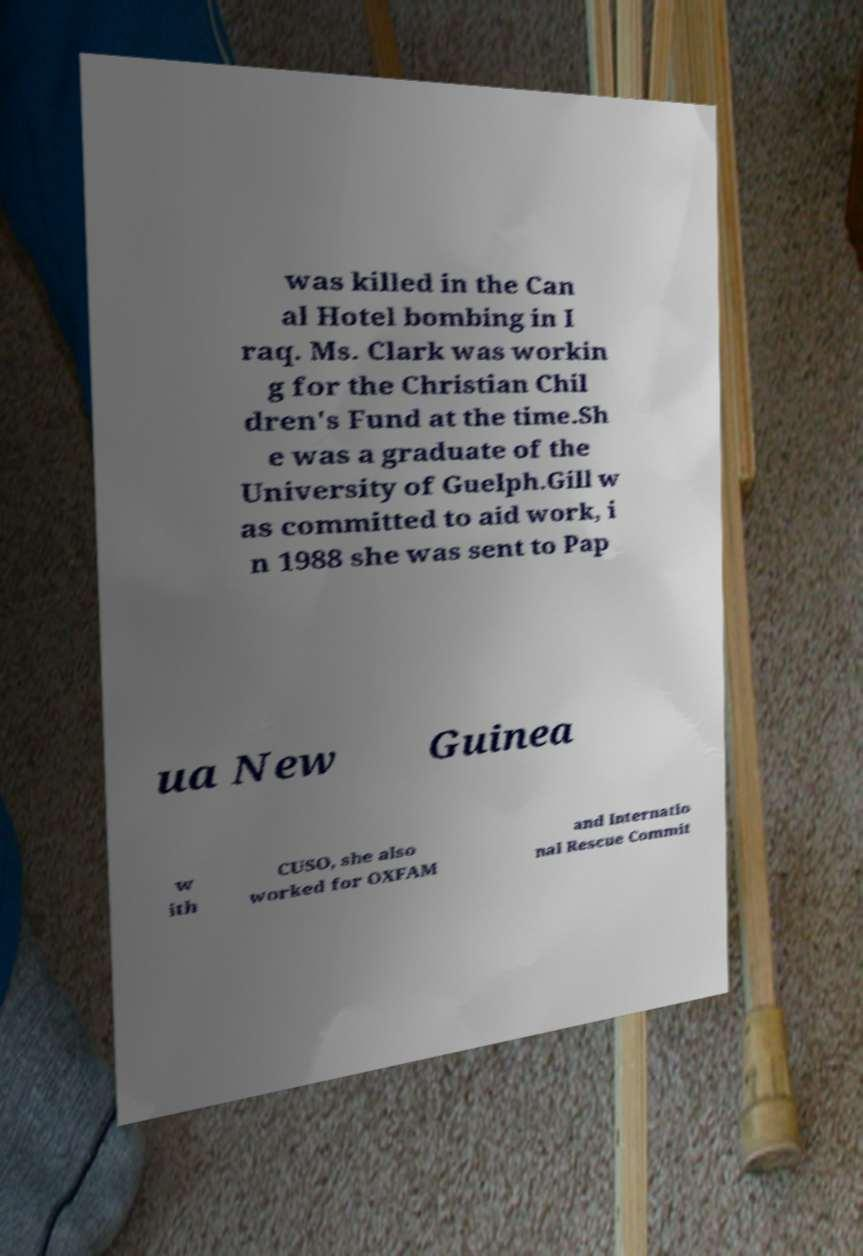Can you read and provide the text displayed in the image?This photo seems to have some interesting text. Can you extract and type it out for me? was killed in the Can al Hotel bombing in I raq. Ms. Clark was workin g for the Christian Chil dren's Fund at the time.Sh e was a graduate of the University of Guelph.Gill w as committed to aid work, i n 1988 she was sent to Pap ua New Guinea w ith CUSO, she also worked for OXFAM and Internatio nal Rescue Commit 